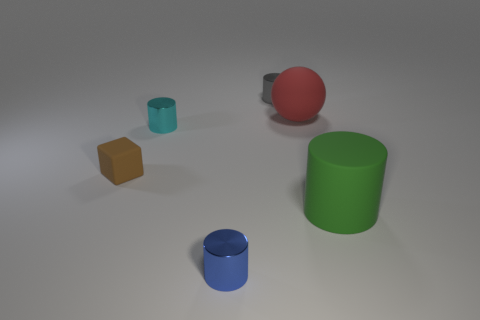Are there any blue metal cylinders left of the tiny blue object?
Provide a short and direct response. No. What color is the small metallic object in front of the matte object that is on the left side of the large matte object that is behind the tiny brown rubber thing?
Provide a succinct answer. Blue. What number of objects are in front of the small gray thing and right of the brown block?
Your answer should be compact. 4. What number of cylinders are either tiny blue shiny things or large green matte things?
Offer a very short reply. 2. Is there a large red matte cylinder?
Your answer should be very brief. No. There is a brown thing that is the same size as the gray metallic cylinder; what material is it?
Offer a very short reply. Rubber. Is the shape of the matte thing that is on the left side of the gray cylinder the same as  the gray thing?
Your response must be concise. No. What number of things are metallic cylinders that are in front of the small gray thing or small cyan rubber balls?
Provide a short and direct response. 2. There is a brown matte thing that is the same size as the blue thing; what shape is it?
Offer a terse response. Cube. Do the thing to the right of the red sphere and the rubber object left of the large matte ball have the same size?
Give a very brief answer. No. 